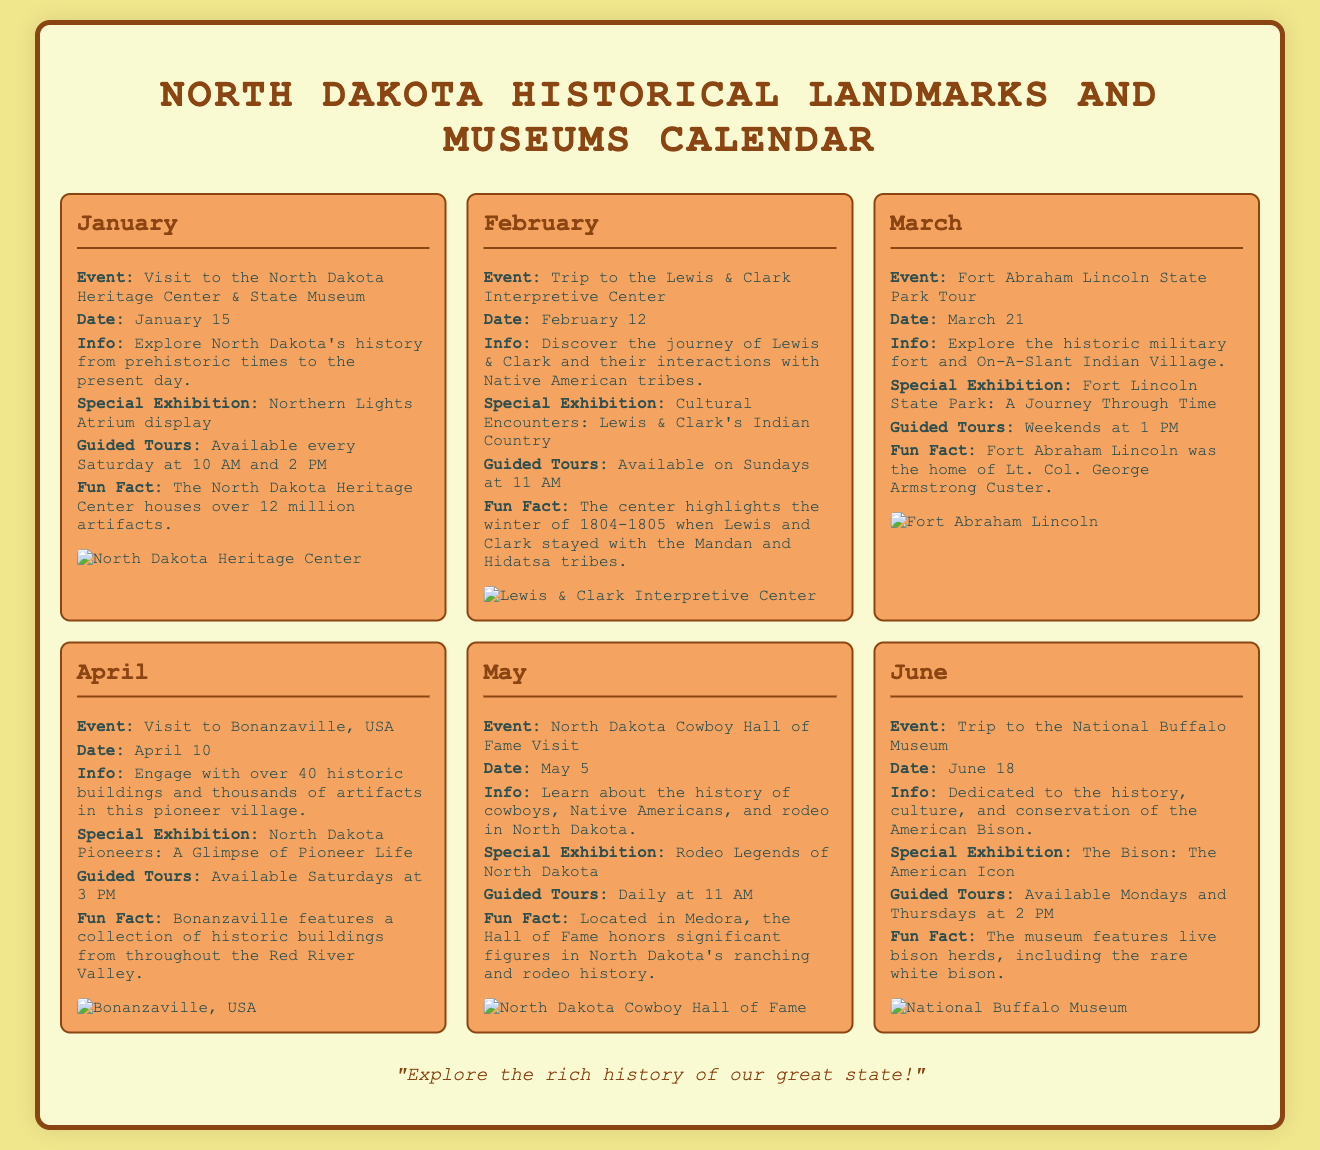What is the date for the visit to the North Dakota Heritage Center? The specific date for the visit is provided in the event information for January.
Answer: January 15 What special exhibition is featured in February? The special exhibition is mentioned in the event section for the Lewis & Clark Interpretive Center.
Answer: Cultural Encounters: Lewis & Clark's Indian Country How many artifacts does the North Dakota Heritage Center house? The number of artifacts is given in the fun fact section of the January event.
Answer: 12 million When are guided tours at Fort Abraham Lincoln State Park available? The schedule for guided tours is detailed in the event information for March.
Answer: Weekends at 1 PM What is the main theme of the North Dakota Cowboy Hall of Fame visit? The theme is summarized in the event information for May.
Answer: History of cowboys, Native Americans, and rodeo What can you expect to see at the National Buffalo Museum? The main focus of the museum is outlined in the information for the June event.
Answer: History, culture, and conservation of the American Bison What is the fun fact about Bonanzaville? The fun fact highlights an aspect of Bonanzaville mentioned in the April event.
Answer: Historic buildings from throughout the Red River Valley Which month features a trip to the Lewis & Clark Interpretive Center? The month is specified in the title of the February event.
Answer: February 